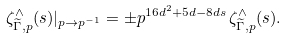Convert formula to latex. <formula><loc_0><loc_0><loc_500><loc_500>\zeta ^ { \wedge } _ { \widetilde { \Gamma } , p } ( s ) | _ { p \to p ^ { - 1 } } = \pm p ^ { 1 6 d ^ { 2 } + 5 d - 8 d s } \, \zeta ^ { \wedge } _ { \widetilde { \Gamma } , p } ( s ) .</formula> 